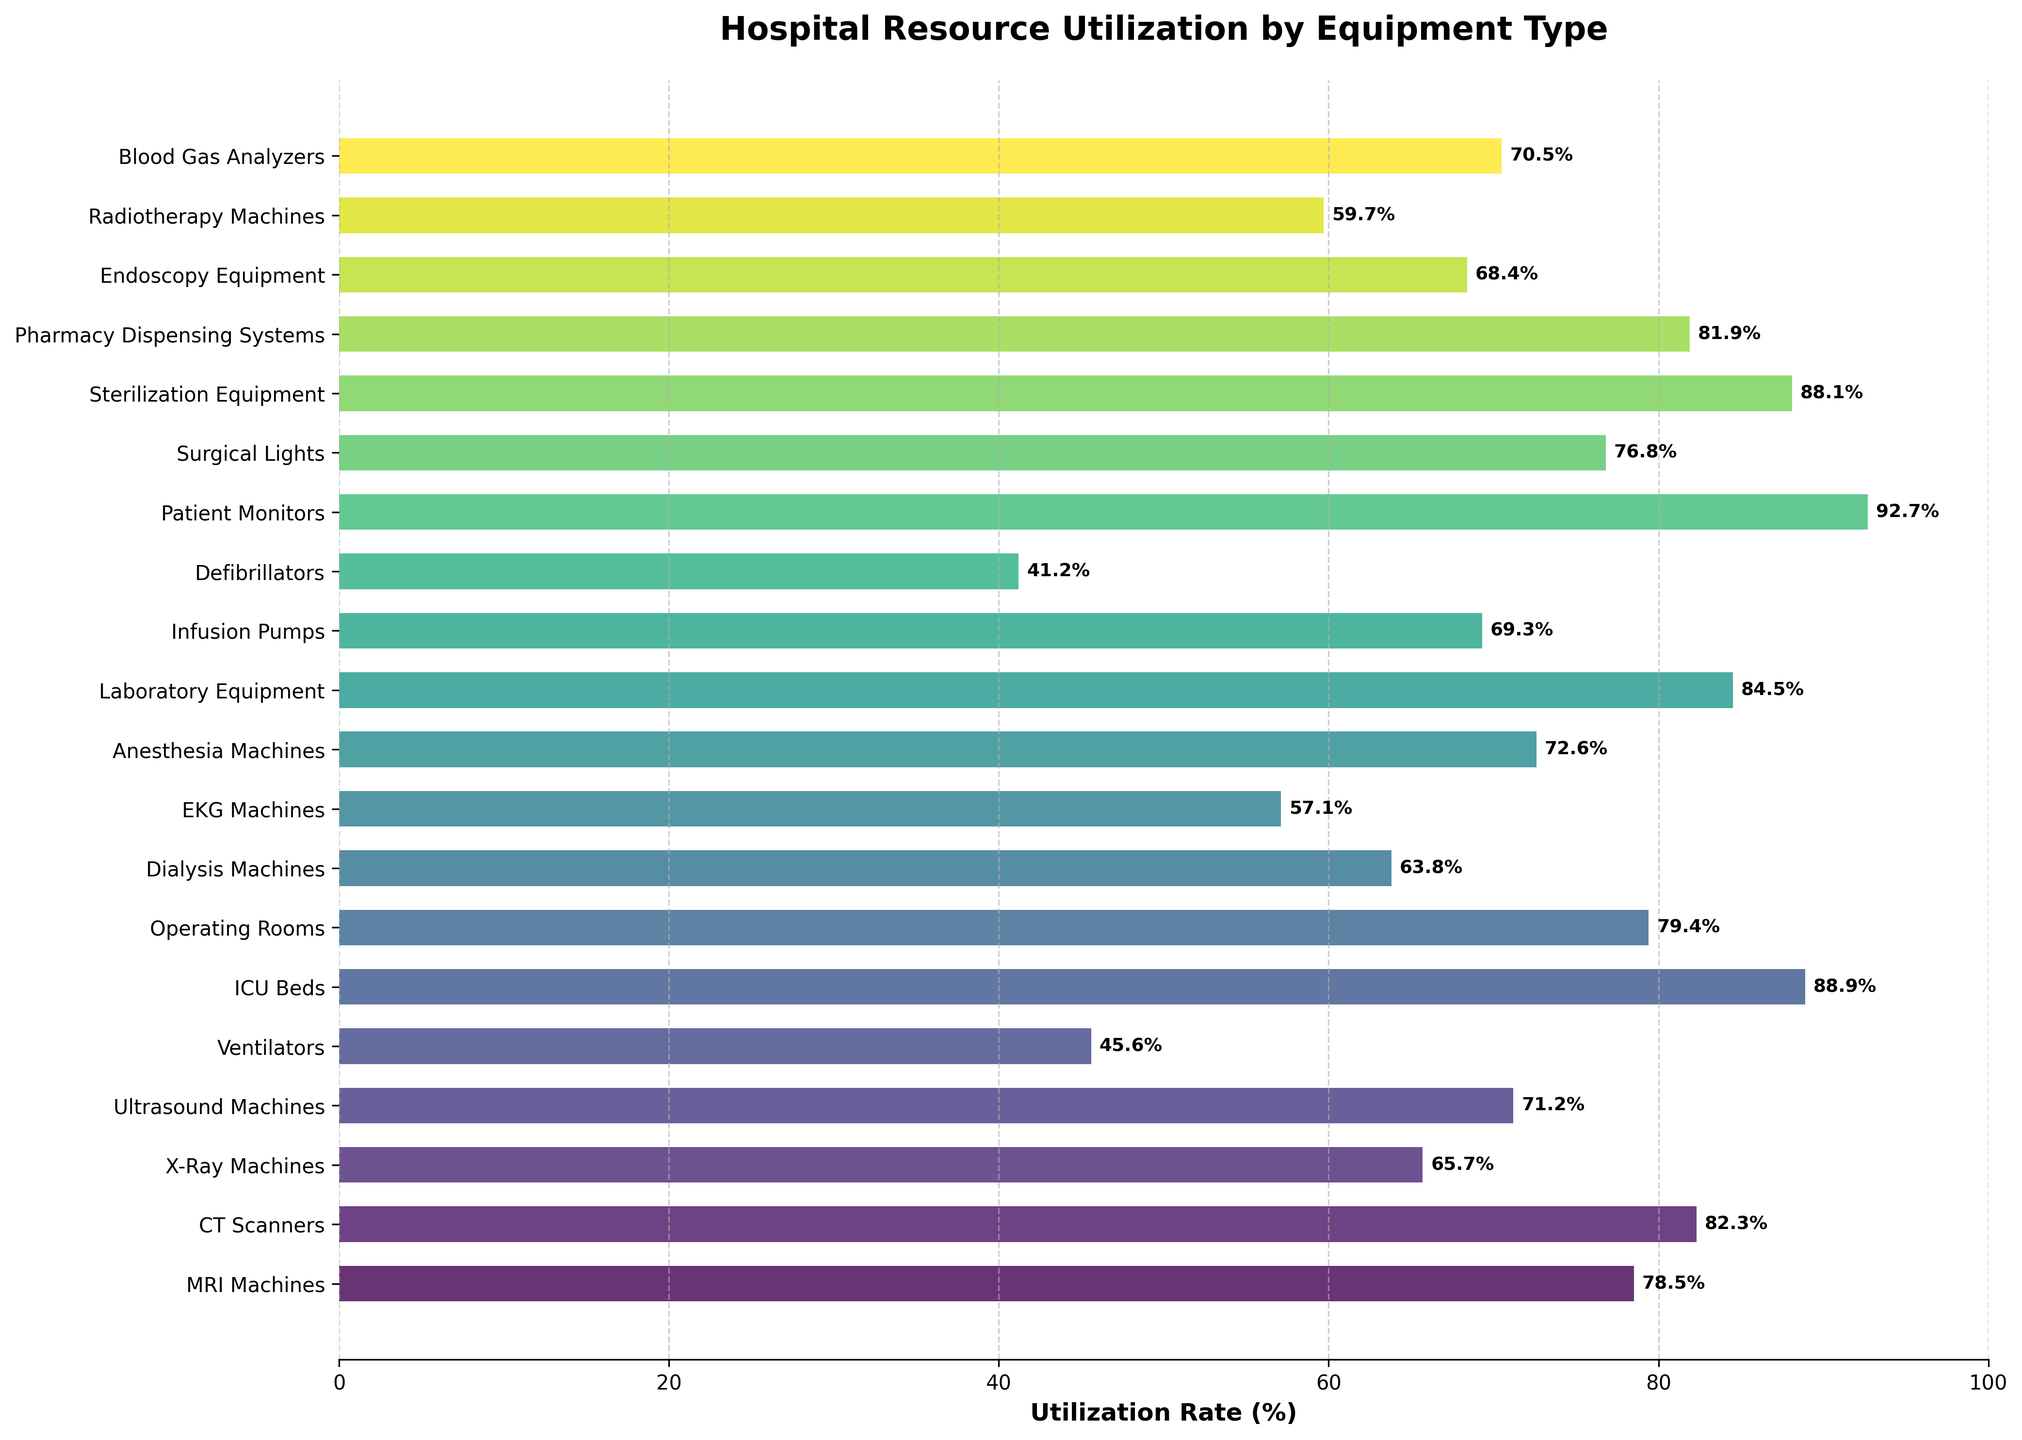Which equipment has the highest utilization rate? The highest utilization rate is visually represented by the tallest horizontal bar in the chart. The equipment with the highest utilization rate is "Patient Monitors" at 92.7%.
Answer: Patient Monitors Which equipment type has the lowest utilization rate, and what is that rate? The lowest utilization rate is visually represented by the shortest horizontal bar in the chart. The equipment type with the lowest utilization rate is "Defibrillators" at 41.2%.
Answer: Defibrillators, 41.2% How much higher is the utilization rate of ICU Beds compared to X-Ray Machines? Find the utilization rates for both ICU Beds and X-Ray Machines from the chart (88.9% and 65.7% respectively) and then subtract the lower rate from the higher rate: 88.9% - 65.7% = 23.2%.
Answer: 23.2% What's the average utilization rate of CT Scanners, Operating Rooms, and Endoscopy Equipment? Add the utilization rates of CT Scanners (82.3%), Operating Rooms (79.4%), and Endoscopy Equipment (68.4%) and then divide by 3: (82.3 + 79.4 + 68.4) / 3 = 76.7%.
Answer: 76.7% List the equipment types with a utilization rate above 80%. Identify the bars with a utilization rate higher than 80%. The equipment types are CT Scanners, ICU Beds, Laboratory Equipment, Patient Monitors, and Pharmacy Dispensing Systems.
Answer: CT Scanners, ICU Beds, Laboratory Equipment, Patient Monitors, Pharmacy Dispensing Systems Which equipment type has a utilization rate closest to the median utilization rate in the dataset? To find the median, sort the utilization rates and find the middle value in the list. With 20 data points, the median is the average of the 10th and 11th values when sorted. These values correspond to Anesthesia Machines and Ultrasound Machines, both with rates close to the middle. The equipment with the utilization rate closest to the median is the Ultrasound Machines with 71.2%.
Answer: Ultrasound Machines Compare the utilization rates of Ventilators and Dialysis Machines. Which has a higher rate? Refer to the chart to find the utilization rates for Ventilators (45.6%) and Dialysis Machines (63.8%). Dialysis Machines have a higher utilization rate.
Answer: Dialysis Machines What is the combined utilization rate of MRI Machines, CT Scanners, and X-Ray Machines? Sum the utilization rates of MRI Machines (78.5%), CT Scanners (82.3%), and X-Ray Machines (65.7%): 78.5 + 82.3 + 65.7 = 226.5%.
Answer: 226.5% What is the utilization rate difference between the highest and lowest utilized equipment? Find the highest utilization rate (Patient Monitors at 92.7%) and the lowest utilization rate (Defibrillators at 41.2%), then subtract the lower rate from the higher rate: 92.7% - 41.2% = 51.5%.
Answer: 51.5% 